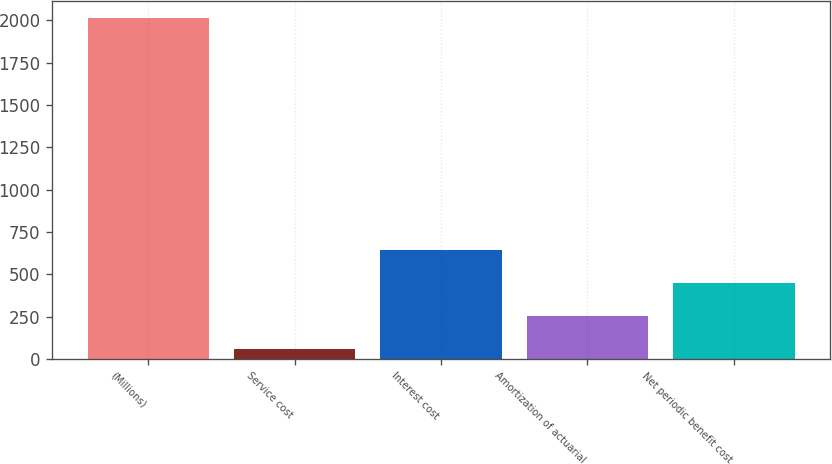Convert chart to OTSL. <chart><loc_0><loc_0><loc_500><loc_500><bar_chart><fcel>(Millions)<fcel>Service cost<fcel>Interest cost<fcel>Amortization of actuarial<fcel>Net periodic benefit cost<nl><fcel>2013<fcel>57<fcel>643.8<fcel>252.6<fcel>448.2<nl></chart> 